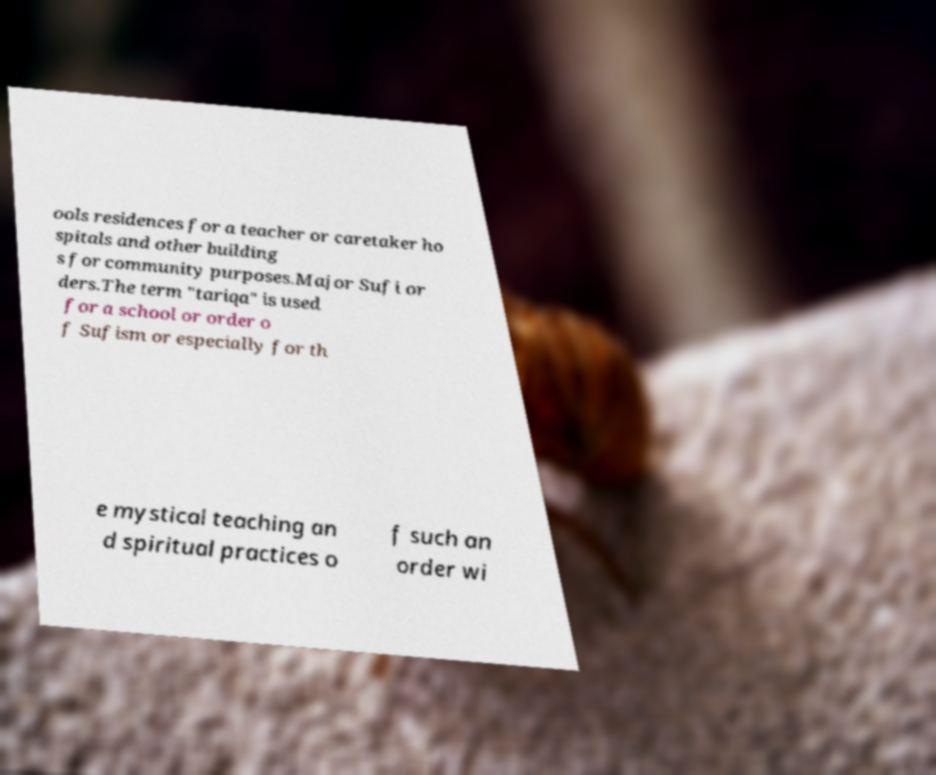For documentation purposes, I need the text within this image transcribed. Could you provide that? ools residences for a teacher or caretaker ho spitals and other building s for community purposes.Major Sufi or ders.The term "tariqa" is used for a school or order o f Sufism or especially for th e mystical teaching an d spiritual practices o f such an order wi 